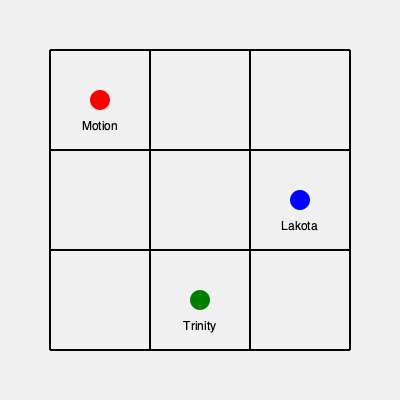In the stylized Bristol city grid above, three iconic underground clubs are marked: Motion (red), Lakota (blue), and Trinity (green). If you start at Motion and want to visit all clubs in the shortest possible route, what is the total distance traveled in city blocks? To solve this problem, we need to follow these steps:

1. Identify the locations of the clubs on the grid:
   - Motion: (1, 1)
   - Lakota: (3, 2)
   - Trinity: (2, 3)

2. Calculate the distances between the clubs:
   a) Motion to Lakota:
      - Horizontal distance: 3 - 1 = 2 blocks
      - Vertical distance: 2 - 1 = 1 block
      - Total: 2 + 1 = 3 blocks

   b) Motion to Trinity:
      - Horizontal distance: 2 - 1 = 1 block
      - Vertical distance: 3 - 1 = 2 blocks
      - Total: 1 + 2 = 3 blocks

   c) Lakota to Trinity:
      - Horizontal distance: 3 - 2 = 1 block
      - Vertical distance: 3 - 2 = 1 block
      - Total: 1 + 1 = 2 blocks

3. Determine the shortest route:
   The shortest route would be Motion → Lakota → Trinity or Motion → Trinity → Lakota.
   Both routes have the same total distance.

4. Calculate the total distance:
   Motion to Lakota (or Trinity): 3 blocks
   Lakota to Trinity (or Trinity to Lakota): 2 blocks
   Total distance: 3 + 2 = 5 blocks

Therefore, the shortest possible route to visit all clubs starting from Motion is 5 city blocks.
Answer: 5 blocks 